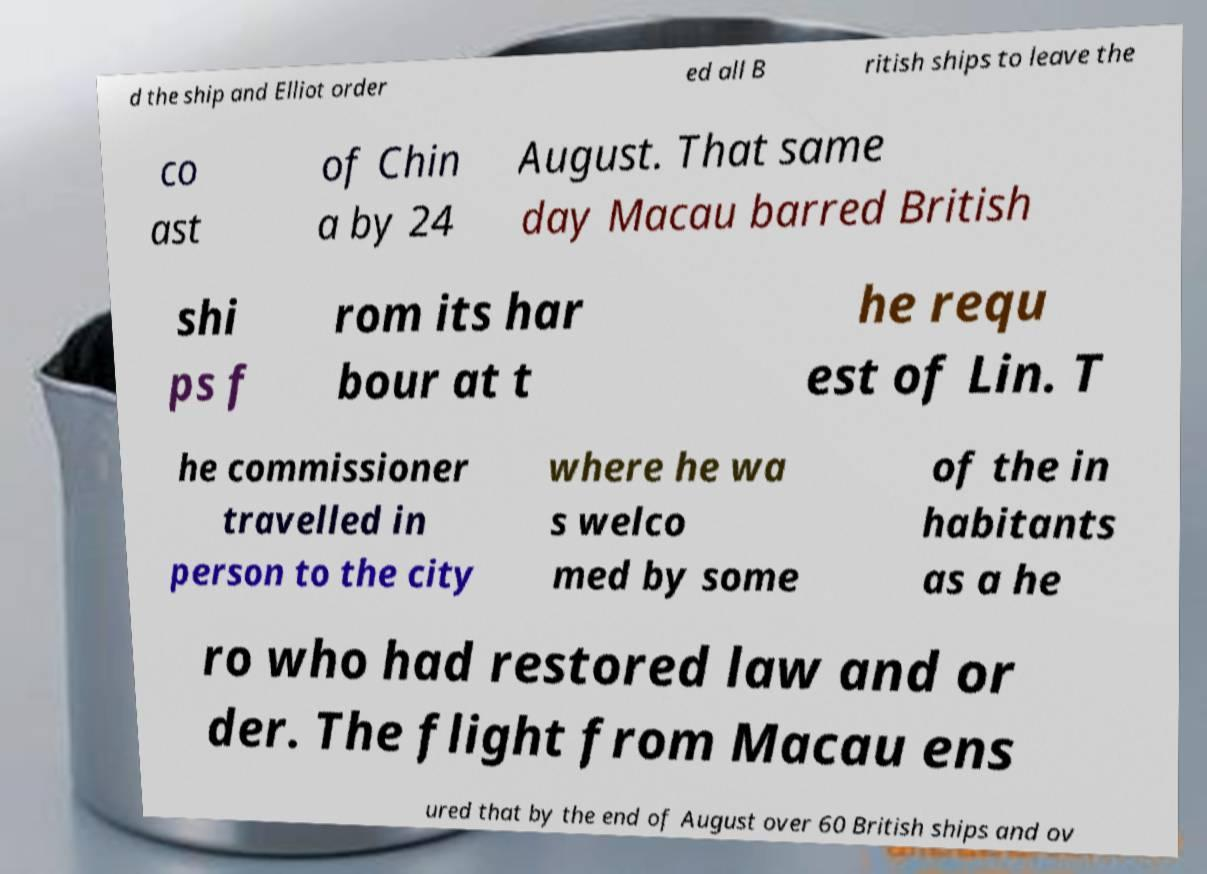Can you accurately transcribe the text from the provided image for me? d the ship and Elliot order ed all B ritish ships to leave the co ast of Chin a by 24 August. That same day Macau barred British shi ps f rom its har bour at t he requ est of Lin. T he commissioner travelled in person to the city where he wa s welco med by some of the in habitants as a he ro who had restored law and or der. The flight from Macau ens ured that by the end of August over 60 British ships and ov 